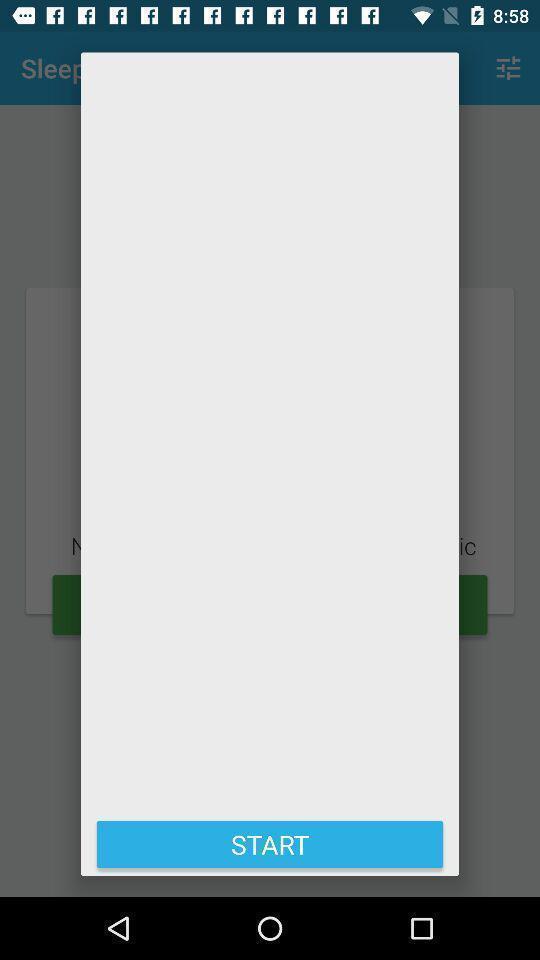Give me a summary of this screen capture. Screen displaying the start page which is empty. 